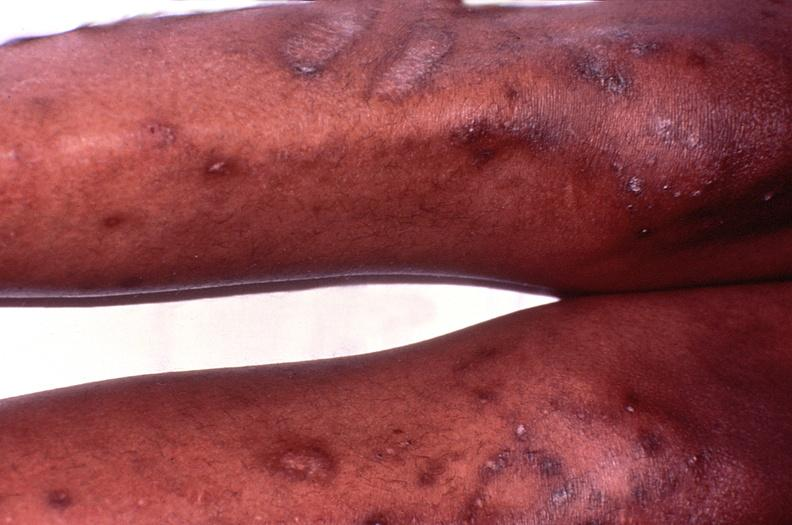what does this image show?
Answer the question using a single word or phrase. Cryptococcal dematitis 